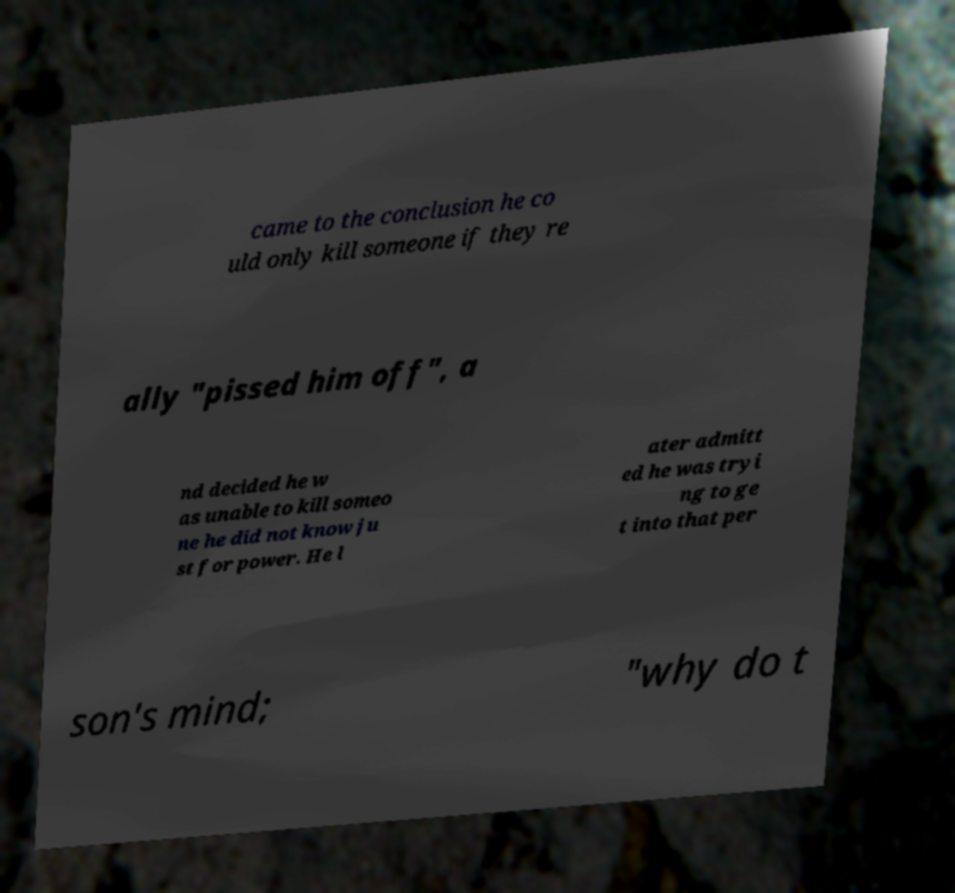Could you assist in decoding the text presented in this image and type it out clearly? came to the conclusion he co uld only kill someone if they re ally "pissed him off", a nd decided he w as unable to kill someo ne he did not know ju st for power. He l ater admitt ed he was tryi ng to ge t into that per son's mind; "why do t 